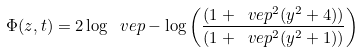<formula> <loc_0><loc_0><loc_500><loc_500>\Phi ( z , t ) = 2 \log \ v e p - \log \left ( \frac { ( 1 + \ v e p ^ { 2 } ( y ^ { 2 } + 4 ) ) } { ( 1 + \ v e p ^ { 2 } ( y ^ { 2 } + 1 ) ) } \right )</formula> 